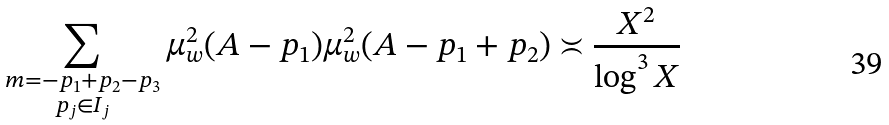Convert formula to latex. <formula><loc_0><loc_0><loc_500><loc_500>\sum _ { \substack { m = - p _ { 1 } + p _ { 2 } - p _ { 3 } \\ p _ { j } \in I _ { j } } } \mu ^ { 2 } _ { w } ( A - p _ { 1 } ) \mu ^ { 2 } _ { w } ( A - p _ { 1 } + p _ { 2 } ) \asymp \frac { X ^ { 2 } } { \log ^ { 3 } X }</formula> 